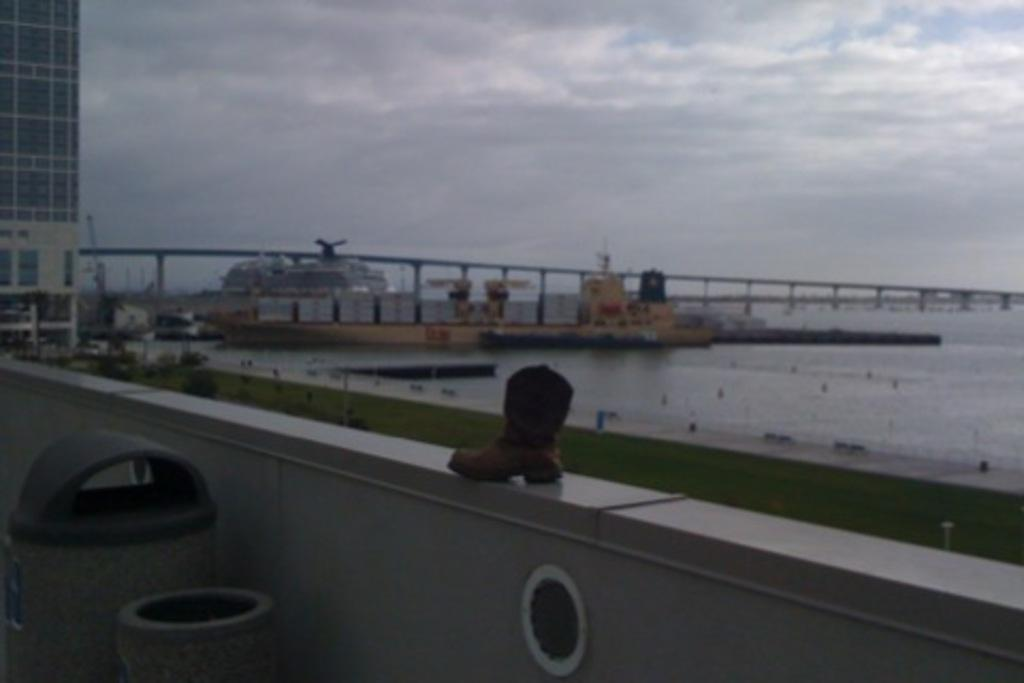What is one of the main features of the image? There is a wall in the image. What is placed on the wall? A shoe is on the wall. What objects are near the wall? There are boxes near the wall. What can be seen in the background of the image? Water, a building, railings, and the sky are visible in the background. How would you describe the appearance of the background? The background appears blurred. What type of waves can be seen crashing against the wall in the image? There are no waves present in the image; it features a shoe on a wall with boxes nearby and a blurred background. 